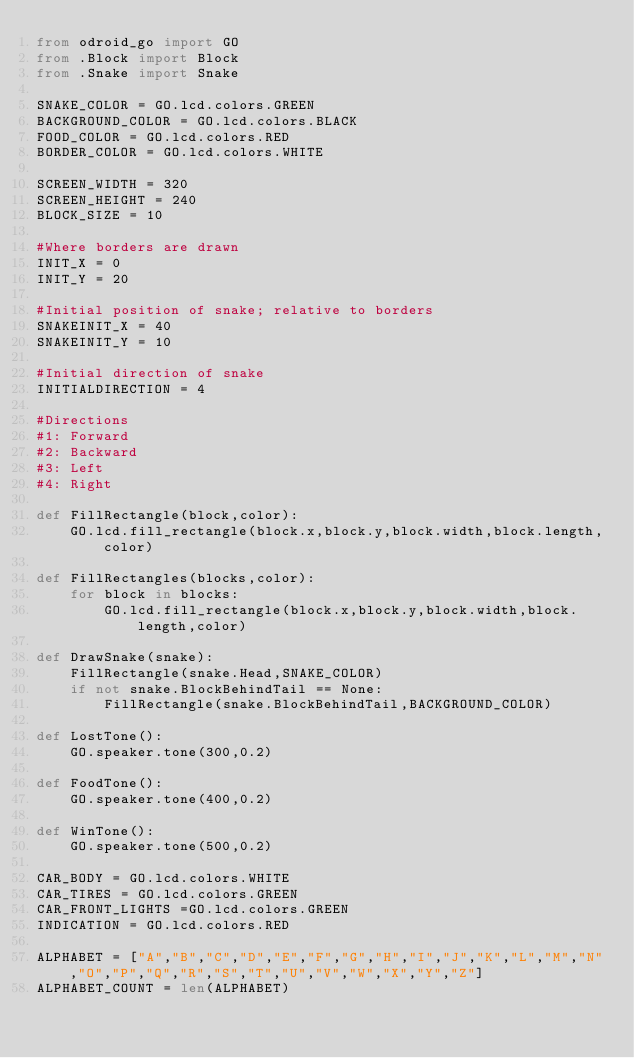<code> <loc_0><loc_0><loc_500><loc_500><_Python_>from odroid_go import GO
from .Block import Block
from .Snake import Snake

SNAKE_COLOR = GO.lcd.colors.GREEN
BACKGROUND_COLOR = GO.lcd.colors.BLACK
FOOD_COLOR = GO.lcd.colors.RED
BORDER_COLOR = GO.lcd.colors.WHITE

SCREEN_WIDTH = 320
SCREEN_HEIGHT = 240
BLOCK_SIZE = 10

#Where borders are drawn
INIT_X = 0
INIT_Y = 20

#Initial position of snake; relative to borders
SNAKEINIT_X = 40
SNAKEINIT_Y = 10

#Initial direction of snake
INITIALDIRECTION = 4

#Directions
#1: Forward
#2: Backward
#3: Left
#4: Right

def FillRectangle(block,color):
    GO.lcd.fill_rectangle(block.x,block.y,block.width,block.length,color)

def FillRectangles(blocks,color):
    for block in blocks:
        GO.lcd.fill_rectangle(block.x,block.y,block.width,block.length,color)

def DrawSnake(snake): 
    FillRectangle(snake.Head,SNAKE_COLOR)
    if not snake.BlockBehindTail == None:
        FillRectangle(snake.BlockBehindTail,BACKGROUND_COLOR)

def LostTone():
    GO.speaker.tone(300,0.2)

def FoodTone():
    GO.speaker.tone(400,0.2)

def WinTone():
    GO.speaker.tone(500,0.2)

CAR_BODY = GO.lcd.colors.WHITE
CAR_TIRES = GO.lcd.colors.GREEN
CAR_FRONT_LIGHTS =GO.lcd.colors.GREEN
INDICATION = GO.lcd.colors.RED

ALPHABET = ["A","B","C","D","E","F","G","H","I","J","K","L","M","N","O","P","Q","R","S","T","U","V","W","X","Y","Z"]
ALPHABET_COUNT = len(ALPHABET)</code> 